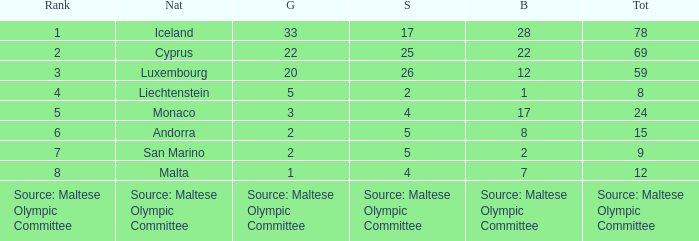What is the number of gold medals when the number of bronze medals is 8? 2.0. Help me parse the entirety of this table. {'header': ['Rank', 'Nat', 'G', 'S', 'B', 'Tot'], 'rows': [['1', 'Iceland', '33', '17', '28', '78'], ['2', 'Cyprus', '22', '25', '22', '69'], ['3', 'Luxembourg', '20', '26', '12', '59'], ['4', 'Liechtenstein', '5', '2', '1', '8'], ['5', 'Monaco', '3', '4', '17', '24'], ['6', 'Andorra', '2', '5', '8', '15'], ['7', 'San Marino', '2', '5', '2', '9'], ['8', 'Malta', '1', '4', '7', '12'], ['Source: Maltese Olympic Committee', 'Source: Maltese Olympic Committee', 'Source: Maltese Olympic Committee', 'Source: Maltese Olympic Committee', 'Source: Maltese Olympic Committee', 'Source: Maltese Olympic Committee']]} 